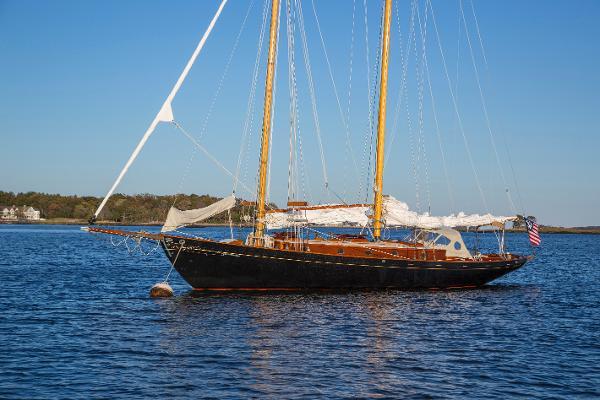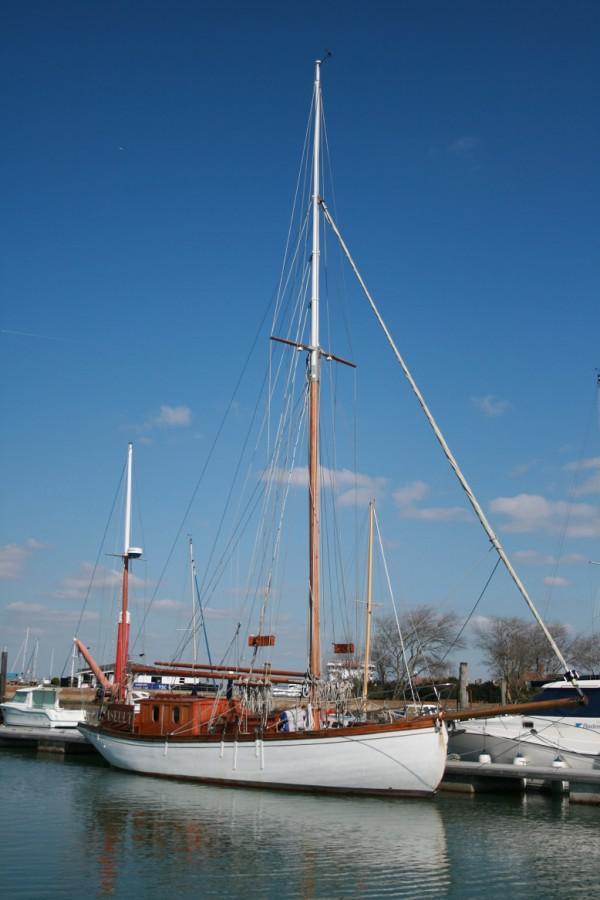The first image is the image on the left, the second image is the image on the right. For the images displayed, is the sentence "At least one boat has a black body." factually correct? Answer yes or no. Yes. 